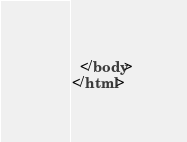Convert code to text. <code><loc_0><loc_0><loc_500><loc_500><_HTML_>  </body>
</html>
</code> 